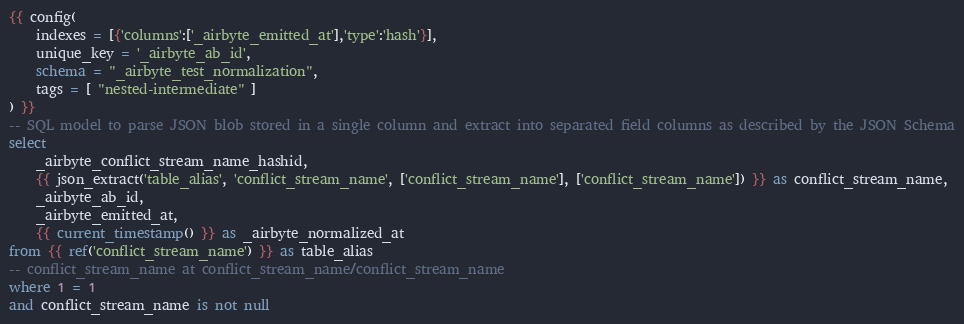Convert code to text. <code><loc_0><loc_0><loc_500><loc_500><_SQL_>{{ config(
    indexes = [{'columns':['_airbyte_emitted_at'],'type':'hash'}],
    unique_key = '_airbyte_ab_id',
    schema = "_airbyte_test_normalization",
    tags = [ "nested-intermediate" ]
) }}
-- SQL model to parse JSON blob stored in a single column and extract into separated field columns as described by the JSON Schema
select
    _airbyte_conflict_stream_name_hashid,
    {{ json_extract('table_alias', 'conflict_stream_name', ['conflict_stream_name'], ['conflict_stream_name']) }} as conflict_stream_name,
    _airbyte_ab_id,
    _airbyte_emitted_at,
    {{ current_timestamp() }} as _airbyte_normalized_at
from {{ ref('conflict_stream_name') }} as table_alias
-- conflict_stream_name at conflict_stream_name/conflict_stream_name
where 1 = 1
and conflict_stream_name is not null

</code> 